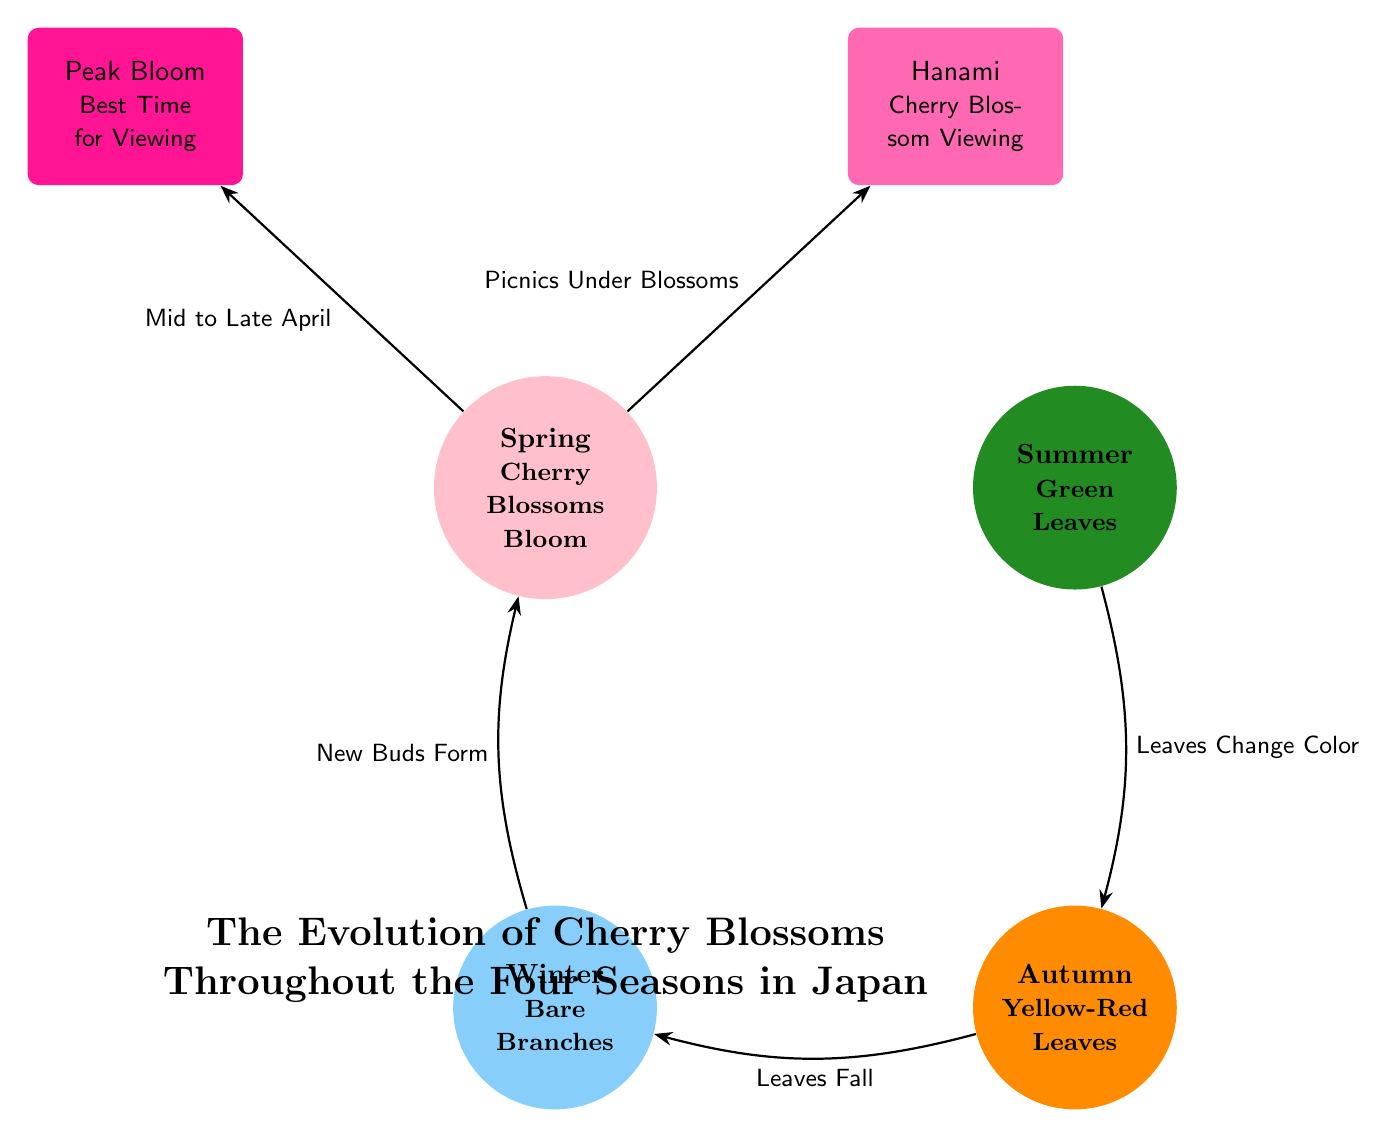What season corresponds to cherry blossoms blooming? The diagram indicates that cherry blossoms bloom during the Spring season.
Answer: Spring What color represents the autumn season in the diagram? The autumn season is represented by the color yellow-red according to the diagram.
Answer: Yellow-Red What event occurs during peak bloom? The diagram states that "Mid to Late April" is the specific time for the peak bloom event associated with cherry blossoms.
Answer: Mid to Late April What happens to the leaves in summer? The diagram illustrates that during summer, the leaves are green, indicating they are in a thriving state.
Answer: Green Leaves What transitions from autumn to winter? The diagram shows that leaves fall as the transition occurs from autumn to winter.
Answer: Leaves Fall What major event is associated with spring? The diagram specifies that cherry blossom viewing, referred to as Hanami, occurs during the spring season.
Answer: Hanami How many main season nodes are depicted in the diagram? There are a total of four main season nodes—Spring, Summer, Autumn, and Winter—present in the diagram.
Answer: Four What is the arrow labeled between spring and summer indicating? The arrow between spring and summer indicates "Petals Fall, Leaves Grow," showing the transition process between these two seasons.
Answer: Petals Fall, Leaves Grow What process occurs in winter according to the diagram? The diagram shows the process of "New Buds Form" occurs during the winter season.
Answer: New Buds Form 